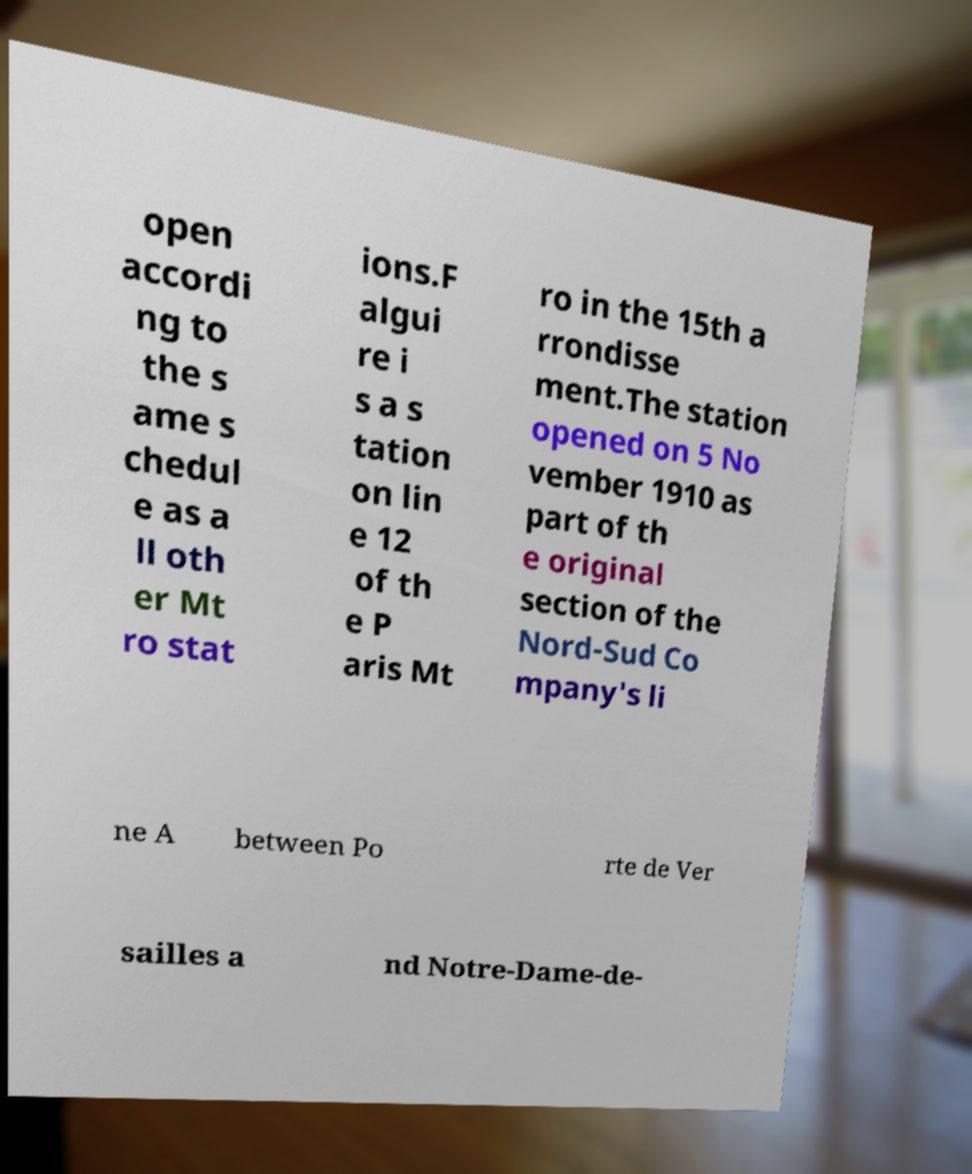Please identify and transcribe the text found in this image. open accordi ng to the s ame s chedul e as a ll oth er Mt ro stat ions.F algui re i s a s tation on lin e 12 of th e P aris Mt ro in the 15th a rrondisse ment.The station opened on 5 No vember 1910 as part of th e original section of the Nord-Sud Co mpany's li ne A between Po rte de Ver sailles a nd Notre-Dame-de- 